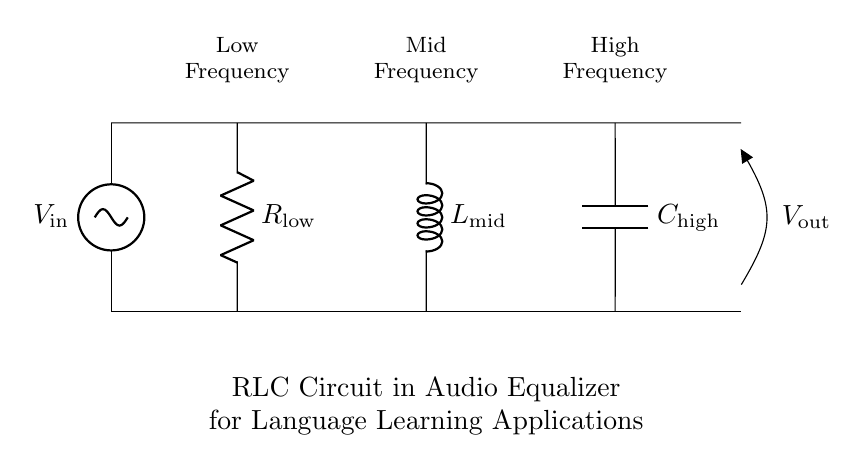What type of circuit is represented? The circuit is an RLC circuit, which includes a resistor, an inductor, and a capacitor, specifically designed for audio equalization.
Answer: RLC circuit What does the voltage source represent? The voltage source represents the input signal, which is an alternating current (AC) signal that drives the circuit.
Answer: Input signal How many components are shown in the circuit? The circuit comprises three main components: a resistor, an inductor, and a capacitor.
Answer: Three What is the purpose of the capacitor in the circuit? The capacitor is typically used to filter high-frequency signals, allowing lower frequencies to pass while blocking higher frequencies.
Answer: Filter high frequencies What frequency range does the resistor target? The resistor is associated with low frequencies, as indicated by the label in the circuit diagram.
Answer: Low frequencies How does the inductor influence mid-range frequencies? The inductor influences mid-range frequencies by allowing them to pass while providing impedance to high frequencies, effectively tuning the circuit to a specific frequency range.
Answer: Allows mid frequencies What is the output voltage's significance in the circuit? The output voltage represents the processed signal after the RLC components have modified the input signal according to their characteristics, indicating the result of equalization.
Answer: Processed signal 